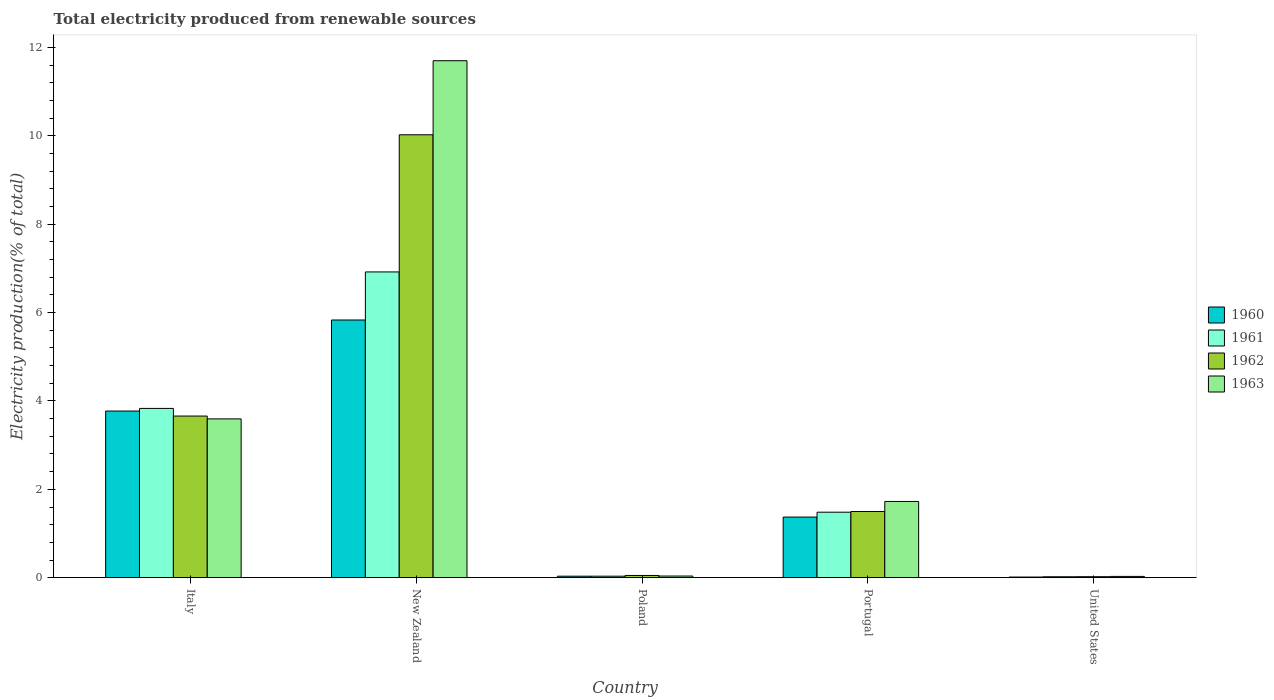How many groups of bars are there?
Offer a very short reply. 5. Are the number of bars per tick equal to the number of legend labels?
Provide a short and direct response. Yes. How many bars are there on the 3rd tick from the left?
Give a very brief answer. 4. How many bars are there on the 5th tick from the right?
Provide a short and direct response. 4. What is the label of the 3rd group of bars from the left?
Keep it short and to the point. Poland. In how many cases, is the number of bars for a given country not equal to the number of legend labels?
Offer a very short reply. 0. What is the total electricity produced in 1963 in Portugal?
Offer a terse response. 1.73. Across all countries, what is the maximum total electricity produced in 1963?
Offer a very short reply. 11.7. Across all countries, what is the minimum total electricity produced in 1962?
Give a very brief answer. 0.02. In which country was the total electricity produced in 1962 maximum?
Provide a short and direct response. New Zealand. What is the total total electricity produced in 1963 in the graph?
Keep it short and to the point. 17.09. What is the difference between the total electricity produced in 1962 in Italy and that in United States?
Provide a succinct answer. 3.64. What is the difference between the total electricity produced in 1962 in Italy and the total electricity produced in 1963 in United States?
Give a very brief answer. 3.63. What is the average total electricity produced in 1962 per country?
Make the answer very short. 3.05. What is the difference between the total electricity produced of/in 1960 and total electricity produced of/in 1962 in Italy?
Make the answer very short. 0.11. What is the ratio of the total electricity produced in 1960 in New Zealand to that in United States?
Your answer should be very brief. 382.31. Is the total electricity produced in 1960 in New Zealand less than that in Portugal?
Your answer should be very brief. No. Is the difference between the total electricity produced in 1960 in New Zealand and Portugal greater than the difference between the total electricity produced in 1962 in New Zealand and Portugal?
Ensure brevity in your answer.  No. What is the difference between the highest and the second highest total electricity produced in 1960?
Keep it short and to the point. -2.4. What is the difference between the highest and the lowest total electricity produced in 1963?
Offer a very short reply. 11.67. In how many countries, is the total electricity produced in 1961 greater than the average total electricity produced in 1961 taken over all countries?
Offer a very short reply. 2. Is it the case that in every country, the sum of the total electricity produced in 1963 and total electricity produced in 1960 is greater than the sum of total electricity produced in 1961 and total electricity produced in 1962?
Ensure brevity in your answer.  No. What does the 3rd bar from the left in Portugal represents?
Your answer should be compact. 1962. What does the 4th bar from the right in Italy represents?
Ensure brevity in your answer.  1960. How many bars are there?
Give a very brief answer. 20. How many countries are there in the graph?
Give a very brief answer. 5. Where does the legend appear in the graph?
Keep it short and to the point. Center right. What is the title of the graph?
Your answer should be very brief. Total electricity produced from renewable sources. What is the Electricity production(% of total) of 1960 in Italy?
Offer a very short reply. 3.77. What is the Electricity production(% of total) in 1961 in Italy?
Give a very brief answer. 3.83. What is the Electricity production(% of total) in 1962 in Italy?
Provide a succinct answer. 3.66. What is the Electricity production(% of total) in 1963 in Italy?
Provide a short and direct response. 3.59. What is the Electricity production(% of total) in 1960 in New Zealand?
Give a very brief answer. 5.83. What is the Electricity production(% of total) of 1961 in New Zealand?
Give a very brief answer. 6.92. What is the Electricity production(% of total) of 1962 in New Zealand?
Offer a terse response. 10.02. What is the Electricity production(% of total) in 1963 in New Zealand?
Keep it short and to the point. 11.7. What is the Electricity production(% of total) in 1960 in Poland?
Your response must be concise. 0.03. What is the Electricity production(% of total) in 1961 in Poland?
Provide a succinct answer. 0.03. What is the Electricity production(% of total) of 1962 in Poland?
Give a very brief answer. 0.05. What is the Electricity production(% of total) in 1963 in Poland?
Provide a short and direct response. 0.04. What is the Electricity production(% of total) in 1960 in Portugal?
Your answer should be compact. 1.37. What is the Electricity production(% of total) in 1961 in Portugal?
Keep it short and to the point. 1.48. What is the Electricity production(% of total) of 1962 in Portugal?
Give a very brief answer. 1.5. What is the Electricity production(% of total) in 1963 in Portugal?
Give a very brief answer. 1.73. What is the Electricity production(% of total) of 1960 in United States?
Your response must be concise. 0.02. What is the Electricity production(% of total) in 1961 in United States?
Provide a succinct answer. 0.02. What is the Electricity production(% of total) of 1962 in United States?
Provide a short and direct response. 0.02. What is the Electricity production(% of total) of 1963 in United States?
Make the answer very short. 0.03. Across all countries, what is the maximum Electricity production(% of total) in 1960?
Ensure brevity in your answer.  5.83. Across all countries, what is the maximum Electricity production(% of total) in 1961?
Make the answer very short. 6.92. Across all countries, what is the maximum Electricity production(% of total) in 1962?
Your answer should be very brief. 10.02. Across all countries, what is the maximum Electricity production(% of total) in 1963?
Provide a short and direct response. 11.7. Across all countries, what is the minimum Electricity production(% of total) of 1960?
Keep it short and to the point. 0.02. Across all countries, what is the minimum Electricity production(% of total) of 1961?
Your response must be concise. 0.02. Across all countries, what is the minimum Electricity production(% of total) of 1962?
Give a very brief answer. 0.02. Across all countries, what is the minimum Electricity production(% of total) in 1963?
Make the answer very short. 0.03. What is the total Electricity production(% of total) in 1960 in the graph?
Provide a short and direct response. 11.03. What is the total Electricity production(% of total) of 1961 in the graph?
Your response must be concise. 12.29. What is the total Electricity production(% of total) of 1962 in the graph?
Give a very brief answer. 15.25. What is the total Electricity production(% of total) in 1963 in the graph?
Your answer should be very brief. 17.09. What is the difference between the Electricity production(% of total) in 1960 in Italy and that in New Zealand?
Provide a short and direct response. -2.06. What is the difference between the Electricity production(% of total) in 1961 in Italy and that in New Zealand?
Provide a short and direct response. -3.09. What is the difference between the Electricity production(% of total) of 1962 in Italy and that in New Zealand?
Ensure brevity in your answer.  -6.37. What is the difference between the Electricity production(% of total) of 1963 in Italy and that in New Zealand?
Your response must be concise. -8.11. What is the difference between the Electricity production(% of total) in 1960 in Italy and that in Poland?
Keep it short and to the point. 3.74. What is the difference between the Electricity production(% of total) in 1961 in Italy and that in Poland?
Provide a succinct answer. 3.8. What is the difference between the Electricity production(% of total) of 1962 in Italy and that in Poland?
Give a very brief answer. 3.61. What is the difference between the Electricity production(% of total) in 1963 in Italy and that in Poland?
Offer a terse response. 3.56. What is the difference between the Electricity production(% of total) in 1960 in Italy and that in Portugal?
Keep it short and to the point. 2.4. What is the difference between the Electricity production(% of total) of 1961 in Italy and that in Portugal?
Keep it short and to the point. 2.35. What is the difference between the Electricity production(% of total) of 1962 in Italy and that in Portugal?
Offer a terse response. 2.16. What is the difference between the Electricity production(% of total) of 1963 in Italy and that in Portugal?
Offer a terse response. 1.87. What is the difference between the Electricity production(% of total) in 1960 in Italy and that in United States?
Provide a short and direct response. 3.76. What is the difference between the Electricity production(% of total) in 1961 in Italy and that in United States?
Make the answer very short. 3.81. What is the difference between the Electricity production(% of total) in 1962 in Italy and that in United States?
Provide a succinct answer. 3.64. What is the difference between the Electricity production(% of total) of 1963 in Italy and that in United States?
Your answer should be compact. 3.56. What is the difference between the Electricity production(% of total) of 1960 in New Zealand and that in Poland?
Provide a succinct answer. 5.8. What is the difference between the Electricity production(% of total) in 1961 in New Zealand and that in Poland?
Provide a succinct answer. 6.89. What is the difference between the Electricity production(% of total) of 1962 in New Zealand and that in Poland?
Ensure brevity in your answer.  9.97. What is the difference between the Electricity production(% of total) in 1963 in New Zealand and that in Poland?
Give a very brief answer. 11.66. What is the difference between the Electricity production(% of total) of 1960 in New Zealand and that in Portugal?
Your answer should be compact. 4.46. What is the difference between the Electricity production(% of total) of 1961 in New Zealand and that in Portugal?
Provide a succinct answer. 5.44. What is the difference between the Electricity production(% of total) of 1962 in New Zealand and that in Portugal?
Ensure brevity in your answer.  8.53. What is the difference between the Electricity production(% of total) in 1963 in New Zealand and that in Portugal?
Ensure brevity in your answer.  9.97. What is the difference between the Electricity production(% of total) of 1960 in New Zealand and that in United States?
Keep it short and to the point. 5.82. What is the difference between the Electricity production(% of total) of 1961 in New Zealand and that in United States?
Make the answer very short. 6.9. What is the difference between the Electricity production(% of total) in 1962 in New Zealand and that in United States?
Provide a short and direct response. 10. What is the difference between the Electricity production(% of total) of 1963 in New Zealand and that in United States?
Provide a short and direct response. 11.67. What is the difference between the Electricity production(% of total) of 1960 in Poland and that in Portugal?
Provide a short and direct response. -1.34. What is the difference between the Electricity production(% of total) of 1961 in Poland and that in Portugal?
Make the answer very short. -1.45. What is the difference between the Electricity production(% of total) of 1962 in Poland and that in Portugal?
Offer a terse response. -1.45. What is the difference between the Electricity production(% of total) in 1963 in Poland and that in Portugal?
Provide a short and direct response. -1.69. What is the difference between the Electricity production(% of total) in 1960 in Poland and that in United States?
Your answer should be compact. 0.02. What is the difference between the Electricity production(% of total) of 1961 in Poland and that in United States?
Offer a very short reply. 0.01. What is the difference between the Electricity production(% of total) in 1962 in Poland and that in United States?
Offer a very short reply. 0.03. What is the difference between the Electricity production(% of total) of 1963 in Poland and that in United States?
Your answer should be compact. 0.01. What is the difference between the Electricity production(% of total) in 1960 in Portugal and that in United States?
Offer a very short reply. 1.36. What is the difference between the Electricity production(% of total) of 1961 in Portugal and that in United States?
Give a very brief answer. 1.46. What is the difference between the Electricity production(% of total) of 1962 in Portugal and that in United States?
Your answer should be very brief. 1.48. What is the difference between the Electricity production(% of total) of 1963 in Portugal and that in United States?
Make the answer very short. 1.7. What is the difference between the Electricity production(% of total) of 1960 in Italy and the Electricity production(% of total) of 1961 in New Zealand?
Ensure brevity in your answer.  -3.15. What is the difference between the Electricity production(% of total) in 1960 in Italy and the Electricity production(% of total) in 1962 in New Zealand?
Make the answer very short. -6.25. What is the difference between the Electricity production(% of total) in 1960 in Italy and the Electricity production(% of total) in 1963 in New Zealand?
Your answer should be very brief. -7.93. What is the difference between the Electricity production(% of total) in 1961 in Italy and the Electricity production(% of total) in 1962 in New Zealand?
Make the answer very short. -6.19. What is the difference between the Electricity production(% of total) in 1961 in Italy and the Electricity production(% of total) in 1963 in New Zealand?
Provide a succinct answer. -7.87. What is the difference between the Electricity production(% of total) in 1962 in Italy and the Electricity production(% of total) in 1963 in New Zealand?
Make the answer very short. -8.04. What is the difference between the Electricity production(% of total) of 1960 in Italy and the Electricity production(% of total) of 1961 in Poland?
Offer a terse response. 3.74. What is the difference between the Electricity production(% of total) in 1960 in Italy and the Electricity production(% of total) in 1962 in Poland?
Provide a succinct answer. 3.72. What is the difference between the Electricity production(% of total) in 1960 in Italy and the Electricity production(% of total) in 1963 in Poland?
Your answer should be compact. 3.73. What is the difference between the Electricity production(% of total) in 1961 in Italy and the Electricity production(% of total) in 1962 in Poland?
Your response must be concise. 3.78. What is the difference between the Electricity production(% of total) in 1961 in Italy and the Electricity production(% of total) in 1963 in Poland?
Keep it short and to the point. 3.79. What is the difference between the Electricity production(% of total) in 1962 in Italy and the Electricity production(% of total) in 1963 in Poland?
Provide a short and direct response. 3.62. What is the difference between the Electricity production(% of total) in 1960 in Italy and the Electricity production(% of total) in 1961 in Portugal?
Keep it short and to the point. 2.29. What is the difference between the Electricity production(% of total) of 1960 in Italy and the Electricity production(% of total) of 1962 in Portugal?
Offer a very short reply. 2.27. What is the difference between the Electricity production(% of total) in 1960 in Italy and the Electricity production(% of total) in 1963 in Portugal?
Offer a terse response. 2.05. What is the difference between the Electricity production(% of total) in 1961 in Italy and the Electricity production(% of total) in 1962 in Portugal?
Give a very brief answer. 2.33. What is the difference between the Electricity production(% of total) of 1961 in Italy and the Electricity production(% of total) of 1963 in Portugal?
Provide a short and direct response. 2.11. What is the difference between the Electricity production(% of total) of 1962 in Italy and the Electricity production(% of total) of 1963 in Portugal?
Your answer should be very brief. 1.93. What is the difference between the Electricity production(% of total) in 1960 in Italy and the Electricity production(% of total) in 1961 in United States?
Give a very brief answer. 3.75. What is the difference between the Electricity production(% of total) of 1960 in Italy and the Electricity production(% of total) of 1962 in United States?
Provide a succinct answer. 3.75. What is the difference between the Electricity production(% of total) in 1960 in Italy and the Electricity production(% of total) in 1963 in United States?
Your answer should be very brief. 3.74. What is the difference between the Electricity production(% of total) in 1961 in Italy and the Electricity production(% of total) in 1962 in United States?
Give a very brief answer. 3.81. What is the difference between the Electricity production(% of total) in 1961 in Italy and the Electricity production(% of total) in 1963 in United States?
Provide a succinct answer. 3.8. What is the difference between the Electricity production(% of total) in 1962 in Italy and the Electricity production(% of total) in 1963 in United States?
Your response must be concise. 3.63. What is the difference between the Electricity production(% of total) of 1960 in New Zealand and the Electricity production(% of total) of 1961 in Poland?
Provide a short and direct response. 5.8. What is the difference between the Electricity production(% of total) in 1960 in New Zealand and the Electricity production(% of total) in 1962 in Poland?
Offer a terse response. 5.78. What is the difference between the Electricity production(% of total) in 1960 in New Zealand and the Electricity production(% of total) in 1963 in Poland?
Keep it short and to the point. 5.79. What is the difference between the Electricity production(% of total) of 1961 in New Zealand and the Electricity production(% of total) of 1962 in Poland?
Your response must be concise. 6.87. What is the difference between the Electricity production(% of total) in 1961 in New Zealand and the Electricity production(% of total) in 1963 in Poland?
Your answer should be very brief. 6.88. What is the difference between the Electricity production(% of total) of 1962 in New Zealand and the Electricity production(% of total) of 1963 in Poland?
Your response must be concise. 9.99. What is the difference between the Electricity production(% of total) of 1960 in New Zealand and the Electricity production(% of total) of 1961 in Portugal?
Keep it short and to the point. 4.35. What is the difference between the Electricity production(% of total) in 1960 in New Zealand and the Electricity production(% of total) in 1962 in Portugal?
Ensure brevity in your answer.  4.33. What is the difference between the Electricity production(% of total) in 1960 in New Zealand and the Electricity production(% of total) in 1963 in Portugal?
Your answer should be compact. 4.11. What is the difference between the Electricity production(% of total) in 1961 in New Zealand and the Electricity production(% of total) in 1962 in Portugal?
Offer a very short reply. 5.42. What is the difference between the Electricity production(% of total) of 1961 in New Zealand and the Electricity production(% of total) of 1963 in Portugal?
Keep it short and to the point. 5.19. What is the difference between the Electricity production(% of total) in 1962 in New Zealand and the Electricity production(% of total) in 1963 in Portugal?
Your answer should be very brief. 8.3. What is the difference between the Electricity production(% of total) in 1960 in New Zealand and the Electricity production(% of total) in 1961 in United States?
Keep it short and to the point. 5.81. What is the difference between the Electricity production(% of total) in 1960 in New Zealand and the Electricity production(% of total) in 1962 in United States?
Your response must be concise. 5.81. What is the difference between the Electricity production(% of total) in 1960 in New Zealand and the Electricity production(% of total) in 1963 in United States?
Your answer should be compact. 5.8. What is the difference between the Electricity production(% of total) of 1961 in New Zealand and the Electricity production(% of total) of 1962 in United States?
Keep it short and to the point. 6.9. What is the difference between the Electricity production(% of total) in 1961 in New Zealand and the Electricity production(% of total) in 1963 in United States?
Your answer should be compact. 6.89. What is the difference between the Electricity production(% of total) of 1962 in New Zealand and the Electricity production(% of total) of 1963 in United States?
Keep it short and to the point. 10. What is the difference between the Electricity production(% of total) in 1960 in Poland and the Electricity production(% of total) in 1961 in Portugal?
Provide a short and direct response. -1.45. What is the difference between the Electricity production(% of total) in 1960 in Poland and the Electricity production(% of total) in 1962 in Portugal?
Offer a terse response. -1.46. What is the difference between the Electricity production(% of total) of 1960 in Poland and the Electricity production(% of total) of 1963 in Portugal?
Ensure brevity in your answer.  -1.69. What is the difference between the Electricity production(% of total) of 1961 in Poland and the Electricity production(% of total) of 1962 in Portugal?
Provide a short and direct response. -1.46. What is the difference between the Electricity production(% of total) of 1961 in Poland and the Electricity production(% of total) of 1963 in Portugal?
Ensure brevity in your answer.  -1.69. What is the difference between the Electricity production(% of total) of 1962 in Poland and the Electricity production(% of total) of 1963 in Portugal?
Make the answer very short. -1.67. What is the difference between the Electricity production(% of total) of 1960 in Poland and the Electricity production(% of total) of 1961 in United States?
Offer a terse response. 0.01. What is the difference between the Electricity production(% of total) in 1960 in Poland and the Electricity production(% of total) in 1962 in United States?
Keep it short and to the point. 0.01. What is the difference between the Electricity production(% of total) in 1960 in Poland and the Electricity production(% of total) in 1963 in United States?
Your answer should be very brief. 0. What is the difference between the Electricity production(% of total) of 1961 in Poland and the Electricity production(% of total) of 1962 in United States?
Offer a very short reply. 0.01. What is the difference between the Electricity production(% of total) in 1961 in Poland and the Electricity production(% of total) in 1963 in United States?
Provide a short and direct response. 0. What is the difference between the Electricity production(% of total) of 1962 in Poland and the Electricity production(% of total) of 1963 in United States?
Offer a terse response. 0.02. What is the difference between the Electricity production(% of total) of 1960 in Portugal and the Electricity production(% of total) of 1961 in United States?
Keep it short and to the point. 1.35. What is the difference between the Electricity production(% of total) of 1960 in Portugal and the Electricity production(% of total) of 1962 in United States?
Ensure brevity in your answer.  1.35. What is the difference between the Electricity production(% of total) of 1960 in Portugal and the Electricity production(% of total) of 1963 in United States?
Your response must be concise. 1.34. What is the difference between the Electricity production(% of total) in 1961 in Portugal and the Electricity production(% of total) in 1962 in United States?
Keep it short and to the point. 1.46. What is the difference between the Electricity production(% of total) of 1961 in Portugal and the Electricity production(% of total) of 1963 in United States?
Provide a short and direct response. 1.45. What is the difference between the Electricity production(% of total) of 1962 in Portugal and the Electricity production(% of total) of 1963 in United States?
Your response must be concise. 1.47. What is the average Electricity production(% of total) of 1960 per country?
Make the answer very short. 2.21. What is the average Electricity production(% of total) of 1961 per country?
Offer a very short reply. 2.46. What is the average Electricity production(% of total) in 1962 per country?
Offer a very short reply. 3.05. What is the average Electricity production(% of total) of 1963 per country?
Your response must be concise. 3.42. What is the difference between the Electricity production(% of total) of 1960 and Electricity production(% of total) of 1961 in Italy?
Offer a very short reply. -0.06. What is the difference between the Electricity production(% of total) in 1960 and Electricity production(% of total) in 1962 in Italy?
Your answer should be compact. 0.11. What is the difference between the Electricity production(% of total) of 1960 and Electricity production(% of total) of 1963 in Italy?
Your answer should be very brief. 0.18. What is the difference between the Electricity production(% of total) in 1961 and Electricity production(% of total) in 1962 in Italy?
Offer a very short reply. 0.17. What is the difference between the Electricity production(% of total) of 1961 and Electricity production(% of total) of 1963 in Italy?
Make the answer very short. 0.24. What is the difference between the Electricity production(% of total) of 1962 and Electricity production(% of total) of 1963 in Italy?
Offer a terse response. 0.06. What is the difference between the Electricity production(% of total) in 1960 and Electricity production(% of total) in 1961 in New Zealand?
Your response must be concise. -1.09. What is the difference between the Electricity production(% of total) in 1960 and Electricity production(% of total) in 1962 in New Zealand?
Offer a very short reply. -4.19. What is the difference between the Electricity production(% of total) in 1960 and Electricity production(% of total) in 1963 in New Zealand?
Give a very brief answer. -5.87. What is the difference between the Electricity production(% of total) in 1961 and Electricity production(% of total) in 1962 in New Zealand?
Provide a succinct answer. -3.1. What is the difference between the Electricity production(% of total) of 1961 and Electricity production(% of total) of 1963 in New Zealand?
Keep it short and to the point. -4.78. What is the difference between the Electricity production(% of total) in 1962 and Electricity production(% of total) in 1963 in New Zealand?
Ensure brevity in your answer.  -1.68. What is the difference between the Electricity production(% of total) in 1960 and Electricity production(% of total) in 1961 in Poland?
Your response must be concise. 0. What is the difference between the Electricity production(% of total) in 1960 and Electricity production(% of total) in 1962 in Poland?
Provide a succinct answer. -0.02. What is the difference between the Electricity production(% of total) in 1960 and Electricity production(% of total) in 1963 in Poland?
Ensure brevity in your answer.  -0. What is the difference between the Electricity production(% of total) of 1961 and Electricity production(% of total) of 1962 in Poland?
Keep it short and to the point. -0.02. What is the difference between the Electricity production(% of total) in 1961 and Electricity production(% of total) in 1963 in Poland?
Keep it short and to the point. -0. What is the difference between the Electricity production(% of total) in 1962 and Electricity production(% of total) in 1963 in Poland?
Your answer should be compact. 0.01. What is the difference between the Electricity production(% of total) in 1960 and Electricity production(% of total) in 1961 in Portugal?
Provide a succinct answer. -0.11. What is the difference between the Electricity production(% of total) of 1960 and Electricity production(% of total) of 1962 in Portugal?
Your answer should be very brief. -0.13. What is the difference between the Electricity production(% of total) in 1960 and Electricity production(% of total) in 1963 in Portugal?
Your answer should be compact. -0.35. What is the difference between the Electricity production(% of total) of 1961 and Electricity production(% of total) of 1962 in Portugal?
Keep it short and to the point. -0.02. What is the difference between the Electricity production(% of total) of 1961 and Electricity production(% of total) of 1963 in Portugal?
Provide a succinct answer. -0.24. What is the difference between the Electricity production(% of total) of 1962 and Electricity production(% of total) of 1963 in Portugal?
Ensure brevity in your answer.  -0.23. What is the difference between the Electricity production(% of total) of 1960 and Electricity production(% of total) of 1961 in United States?
Offer a terse response. -0.01. What is the difference between the Electricity production(% of total) in 1960 and Electricity production(% of total) in 1962 in United States?
Offer a terse response. -0.01. What is the difference between the Electricity production(% of total) in 1960 and Electricity production(% of total) in 1963 in United States?
Give a very brief answer. -0.01. What is the difference between the Electricity production(% of total) in 1961 and Electricity production(% of total) in 1962 in United States?
Offer a terse response. -0. What is the difference between the Electricity production(% of total) of 1961 and Electricity production(% of total) of 1963 in United States?
Ensure brevity in your answer.  -0.01. What is the difference between the Electricity production(% of total) of 1962 and Electricity production(% of total) of 1963 in United States?
Your response must be concise. -0.01. What is the ratio of the Electricity production(% of total) of 1960 in Italy to that in New Zealand?
Give a very brief answer. 0.65. What is the ratio of the Electricity production(% of total) of 1961 in Italy to that in New Zealand?
Keep it short and to the point. 0.55. What is the ratio of the Electricity production(% of total) in 1962 in Italy to that in New Zealand?
Provide a succinct answer. 0.36. What is the ratio of the Electricity production(% of total) in 1963 in Italy to that in New Zealand?
Give a very brief answer. 0.31. What is the ratio of the Electricity production(% of total) of 1960 in Italy to that in Poland?
Offer a very short reply. 110.45. What is the ratio of the Electricity production(% of total) of 1961 in Italy to that in Poland?
Provide a short and direct response. 112.3. What is the ratio of the Electricity production(% of total) in 1962 in Italy to that in Poland?
Make the answer very short. 71.88. What is the ratio of the Electricity production(% of total) in 1963 in Italy to that in Poland?
Provide a succinct answer. 94.84. What is the ratio of the Electricity production(% of total) of 1960 in Italy to that in Portugal?
Keep it short and to the point. 2.75. What is the ratio of the Electricity production(% of total) of 1961 in Italy to that in Portugal?
Keep it short and to the point. 2.58. What is the ratio of the Electricity production(% of total) in 1962 in Italy to that in Portugal?
Your answer should be very brief. 2.44. What is the ratio of the Electricity production(% of total) of 1963 in Italy to that in Portugal?
Your answer should be compact. 2.08. What is the ratio of the Electricity production(% of total) of 1960 in Italy to that in United States?
Your answer should be compact. 247.25. What is the ratio of the Electricity production(% of total) in 1961 in Italy to that in United States?
Your answer should be compact. 177.87. What is the ratio of the Electricity production(% of total) in 1962 in Italy to that in United States?
Your answer should be compact. 160.56. What is the ratio of the Electricity production(% of total) of 1963 in Italy to that in United States?
Make the answer very short. 122.12. What is the ratio of the Electricity production(% of total) in 1960 in New Zealand to that in Poland?
Your answer should be compact. 170.79. What is the ratio of the Electricity production(% of total) in 1961 in New Zealand to that in Poland?
Your response must be concise. 202.83. What is the ratio of the Electricity production(% of total) in 1962 in New Zealand to that in Poland?
Provide a short and direct response. 196.95. What is the ratio of the Electricity production(% of total) in 1963 in New Zealand to that in Poland?
Keep it short and to the point. 308.73. What is the ratio of the Electricity production(% of total) of 1960 in New Zealand to that in Portugal?
Give a very brief answer. 4.25. What is the ratio of the Electricity production(% of total) in 1961 in New Zealand to that in Portugal?
Make the answer very short. 4.67. What is the ratio of the Electricity production(% of total) of 1962 in New Zealand to that in Portugal?
Offer a very short reply. 6.69. What is the ratio of the Electricity production(% of total) in 1963 in New Zealand to that in Portugal?
Ensure brevity in your answer.  6.78. What is the ratio of the Electricity production(% of total) in 1960 in New Zealand to that in United States?
Your response must be concise. 382.31. What is the ratio of the Electricity production(% of total) in 1961 in New Zealand to that in United States?
Offer a terse response. 321.25. What is the ratio of the Electricity production(% of total) in 1962 in New Zealand to that in United States?
Keep it short and to the point. 439.93. What is the ratio of the Electricity production(% of total) in 1963 in New Zealand to that in United States?
Your response must be concise. 397.5. What is the ratio of the Electricity production(% of total) in 1960 in Poland to that in Portugal?
Your answer should be very brief. 0.02. What is the ratio of the Electricity production(% of total) in 1961 in Poland to that in Portugal?
Offer a very short reply. 0.02. What is the ratio of the Electricity production(% of total) in 1962 in Poland to that in Portugal?
Offer a terse response. 0.03. What is the ratio of the Electricity production(% of total) in 1963 in Poland to that in Portugal?
Your response must be concise. 0.02. What is the ratio of the Electricity production(% of total) of 1960 in Poland to that in United States?
Provide a short and direct response. 2.24. What is the ratio of the Electricity production(% of total) of 1961 in Poland to that in United States?
Offer a terse response. 1.58. What is the ratio of the Electricity production(% of total) of 1962 in Poland to that in United States?
Your response must be concise. 2.23. What is the ratio of the Electricity production(% of total) in 1963 in Poland to that in United States?
Provide a succinct answer. 1.29. What is the ratio of the Electricity production(% of total) in 1960 in Portugal to that in United States?
Your answer should be very brief. 89.96. What is the ratio of the Electricity production(% of total) of 1961 in Portugal to that in United States?
Your answer should be compact. 68.83. What is the ratio of the Electricity production(% of total) in 1962 in Portugal to that in United States?
Ensure brevity in your answer.  65.74. What is the ratio of the Electricity production(% of total) in 1963 in Portugal to that in United States?
Offer a terse response. 58.63. What is the difference between the highest and the second highest Electricity production(% of total) in 1960?
Make the answer very short. 2.06. What is the difference between the highest and the second highest Electricity production(% of total) in 1961?
Ensure brevity in your answer.  3.09. What is the difference between the highest and the second highest Electricity production(% of total) of 1962?
Offer a very short reply. 6.37. What is the difference between the highest and the second highest Electricity production(% of total) of 1963?
Ensure brevity in your answer.  8.11. What is the difference between the highest and the lowest Electricity production(% of total) of 1960?
Keep it short and to the point. 5.82. What is the difference between the highest and the lowest Electricity production(% of total) of 1961?
Make the answer very short. 6.9. What is the difference between the highest and the lowest Electricity production(% of total) of 1962?
Ensure brevity in your answer.  10. What is the difference between the highest and the lowest Electricity production(% of total) of 1963?
Offer a very short reply. 11.67. 